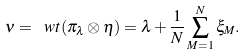Convert formula to latex. <formula><loc_0><loc_0><loc_500><loc_500>\nu = \ w t ( \pi _ { \lambda } \otimes \eta ) = \lambda + \frac { 1 } { N } \sum _ { M = 1 } ^ { N } \xi _ { M } .</formula> 